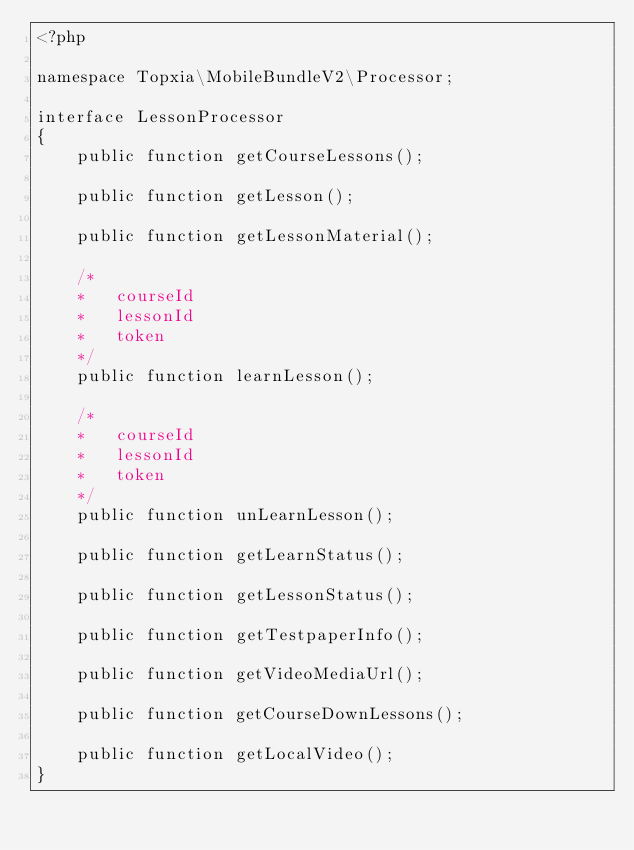<code> <loc_0><loc_0><loc_500><loc_500><_PHP_><?php

namespace Topxia\MobileBundleV2\Processor;

interface LessonProcessor
{
    public function getCourseLessons();

    public function getLesson();

    public function getLessonMaterial();

    /*
    * 	courseId
    *	lessonId
    *	token
    */
    public function learnLesson();

    /*
    * 	courseId
    *	lessonId
    *	token
    */
    public function unLearnLesson();

    public function getLearnStatus();

    public function getLessonStatus();

    public function getTestpaperInfo();

    public function getVideoMediaUrl();

    public function getCourseDownLessons();

    public function getLocalVideo();
}
</code> 